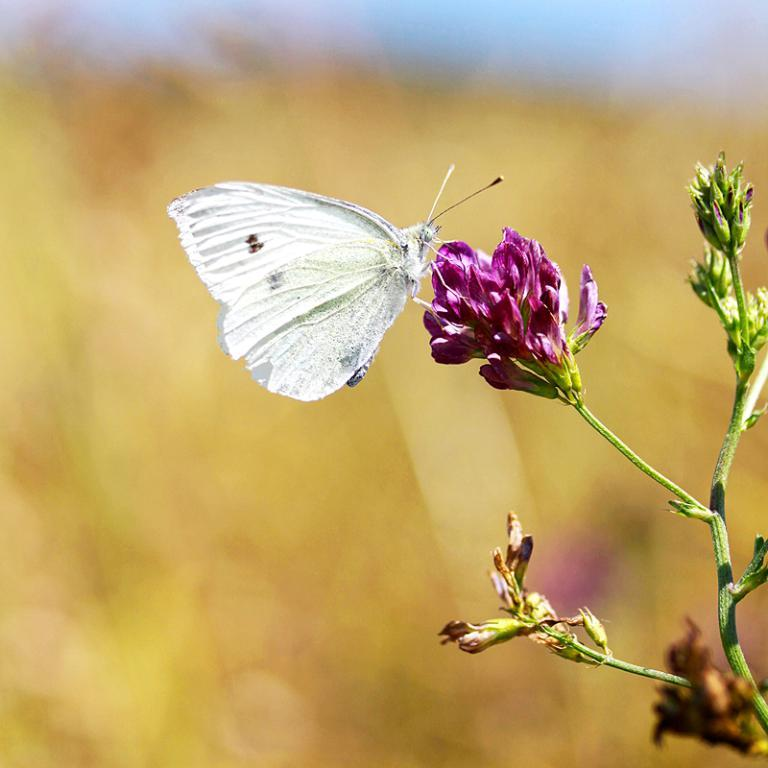What can be seen on the right side of the image? There is a plant with a flower on the right side of the image. What color is the flower? The flower is in violet color. Is there any animal present in the image? Yes, there is a white color butterfly on the flower. How would you describe the background of the image? The background of the image is blurred. How many books can be seen in the image? There are no books present in the image; it features a plant with a flower and a butterfly. Can you tell me the breed of the hen in the image? There is no hen present in the image; it features a plant with a flower and a butterfly. 